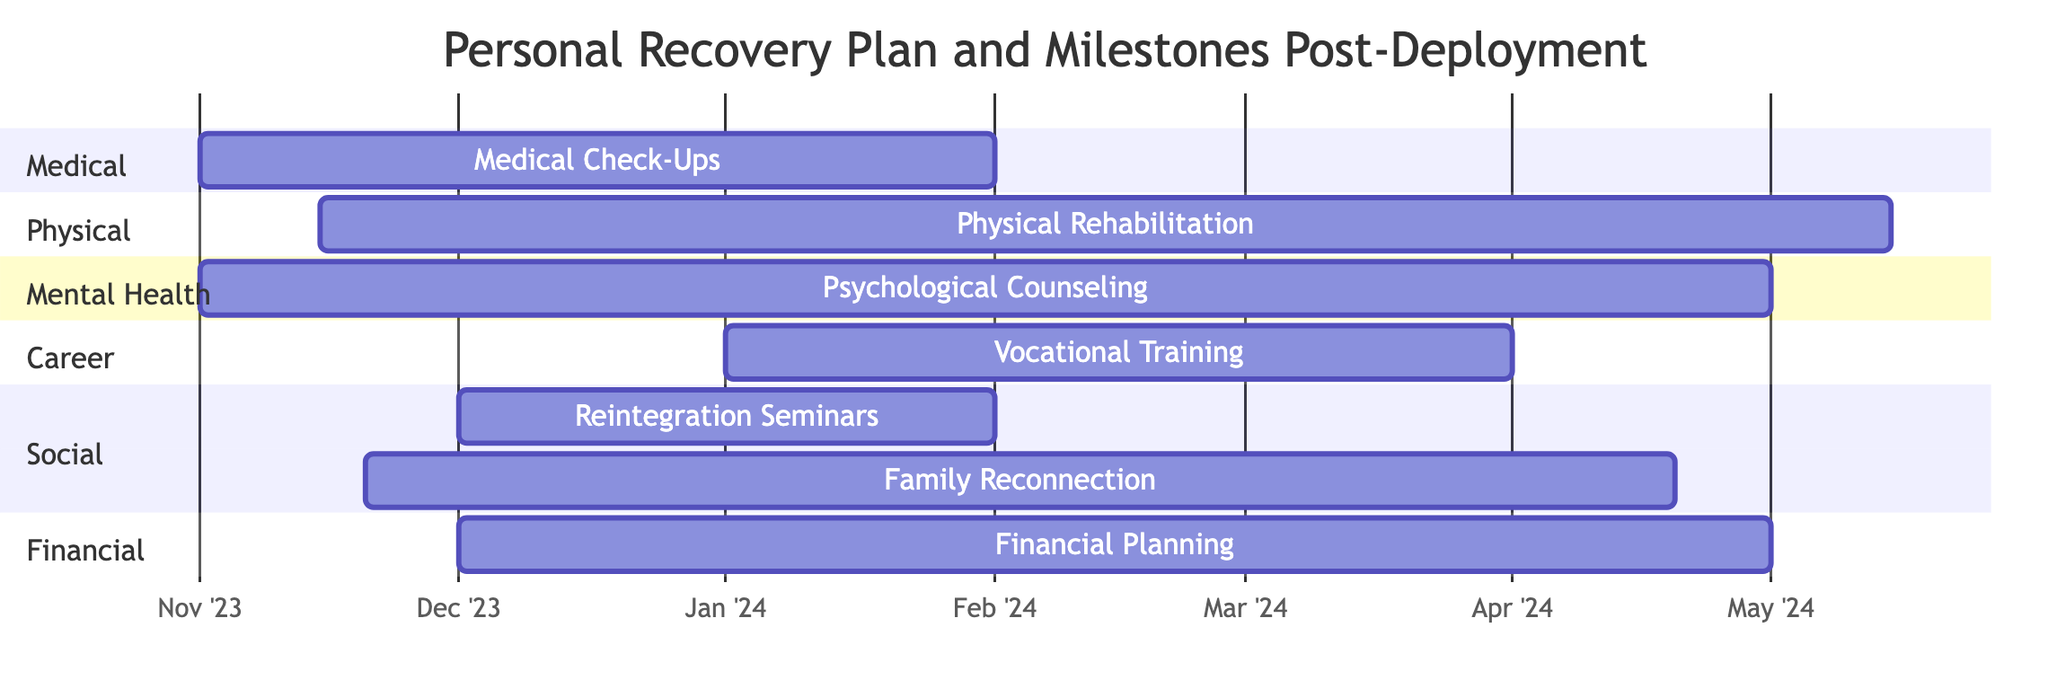What is the duration of the Medical Check-Ups task? The Medical Check-Ups task starts on November 1, 2023, and ends on February 1, 2024. Calculating the duration involves finding the difference between the start and end dates, which is approximately three months.
Answer: three months How many tasks start in November 2023? In November 2023, the tasks that begin are Medical Check-Ups (November 1) and Psychological Counseling (November 1), and Family Reconnection Activities (November 20), making a total of three tasks.
Answer: three tasks What task ends on May 1, 2024? The Psychological Counseling task ends on May 1, 2024, as indicated in the timeline.
Answer: Psychological Counseling Which tasks are part of the Physical section? The Physical section contains just one task, which is Physical Rehabilitation, starting on November 15, 2023, and ending on May 15, 2024.
Answer: Physical Rehabilitation What is the end date for the Family Reconnection Activities? The Family Reconnection Activities task is scheduled to end on April 20, 2024, as per the Gantt chart.
Answer: April 20, 2024 Which tasks overlap with the Psychological Counseling task? The Psychological Counseling task overlaps with Medical Check-Ups (2023-11-01 to 2024-02-01), Physical Rehabilitation (2023-11-15 to 2024-05-15), Family Reconnection Activities (2023-11-20 to 2024-04-20), and Financial Planning and Support (2023-12-01 to 2024-05-01). Thus, four tasks overlap with it.
Answer: four tasks How many tasks are scheduled to start in 2024? In 2024, the tasks scheduled to begin are Vocational Training (January 1), making it just one task that starts in that year.
Answer: one task 